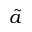<formula> <loc_0><loc_0><loc_500><loc_500>\tilde { a }</formula> 